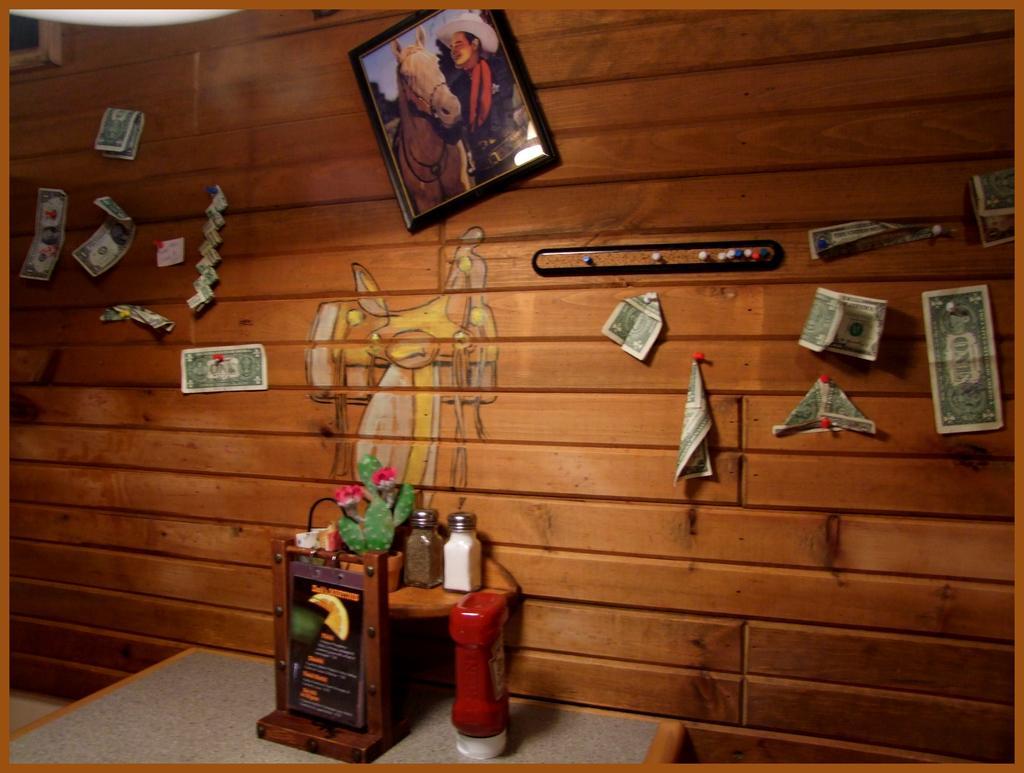Can you describe this image briefly? This image is taken indoors. In the background there is a wall with a painting, a picture frame and a few currency notes pinned with a few pins. At the bottom of the image there is a table with a few things on it. 